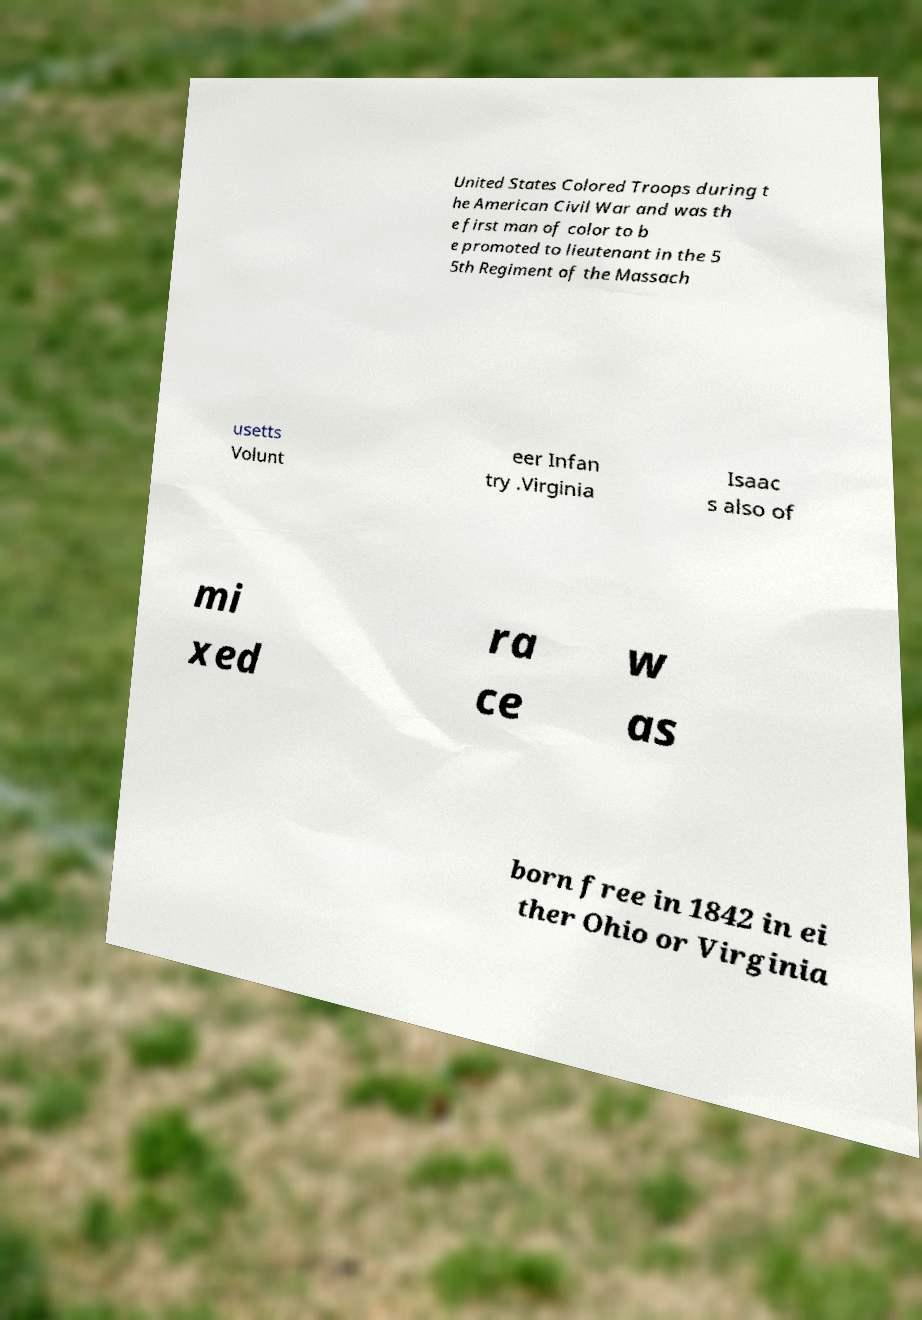Please read and relay the text visible in this image. What does it say? United States Colored Troops during t he American Civil War and was th e first man of color to b e promoted to lieutenant in the 5 5th Regiment of the Massach usetts Volunt eer Infan try .Virginia Isaac s also of mi xed ra ce w as born free in 1842 in ei ther Ohio or Virginia 